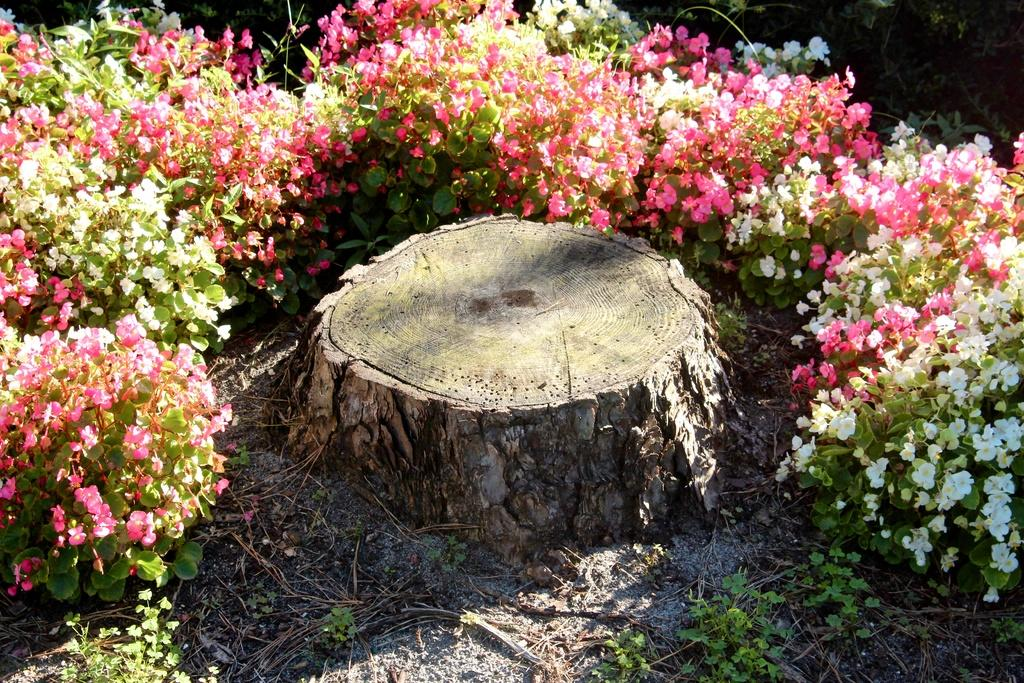What types of vegetation can be seen in the image? There are flowers and plants in the image. What is the condition of the grass at the bottom of the image? The grass at the bottom of the image is dry. Where is the tree located in the image? There is a tree in the center of the image. What type of ring can be seen on the tree in the image? There is no ring present on the tree in the image. What kind of jewel can be found in the library depicted in the image? There is no library depicted in the image, so it is not possible to determine what kind of jewel might be found there. 